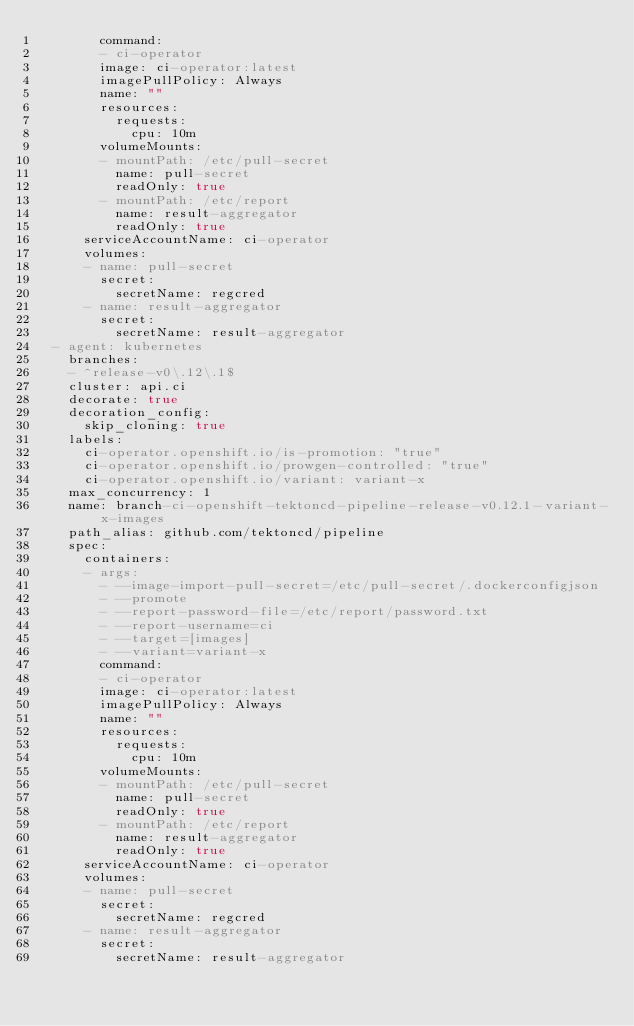<code> <loc_0><loc_0><loc_500><loc_500><_YAML_>        command:
        - ci-operator
        image: ci-operator:latest
        imagePullPolicy: Always
        name: ""
        resources:
          requests:
            cpu: 10m
        volumeMounts:
        - mountPath: /etc/pull-secret
          name: pull-secret
          readOnly: true
        - mountPath: /etc/report
          name: result-aggregator
          readOnly: true
      serviceAccountName: ci-operator
      volumes:
      - name: pull-secret
        secret:
          secretName: regcred
      - name: result-aggregator
        secret:
          secretName: result-aggregator
  - agent: kubernetes
    branches:
    - ^release-v0\.12\.1$
    cluster: api.ci
    decorate: true
    decoration_config:
      skip_cloning: true
    labels:
      ci-operator.openshift.io/is-promotion: "true"
      ci-operator.openshift.io/prowgen-controlled: "true"
      ci-operator.openshift.io/variant: variant-x
    max_concurrency: 1
    name: branch-ci-openshift-tektoncd-pipeline-release-v0.12.1-variant-x-images
    path_alias: github.com/tektoncd/pipeline
    spec:
      containers:
      - args:
        - --image-import-pull-secret=/etc/pull-secret/.dockerconfigjson
        - --promote
        - --report-password-file=/etc/report/password.txt
        - --report-username=ci
        - --target=[images]
        - --variant=variant-x
        command:
        - ci-operator
        image: ci-operator:latest
        imagePullPolicy: Always
        name: ""
        resources:
          requests:
            cpu: 10m
        volumeMounts:
        - mountPath: /etc/pull-secret
          name: pull-secret
          readOnly: true
        - mountPath: /etc/report
          name: result-aggregator
          readOnly: true
      serviceAccountName: ci-operator
      volumes:
      - name: pull-secret
        secret:
          secretName: regcred
      - name: result-aggregator
        secret:
          secretName: result-aggregator
</code> 